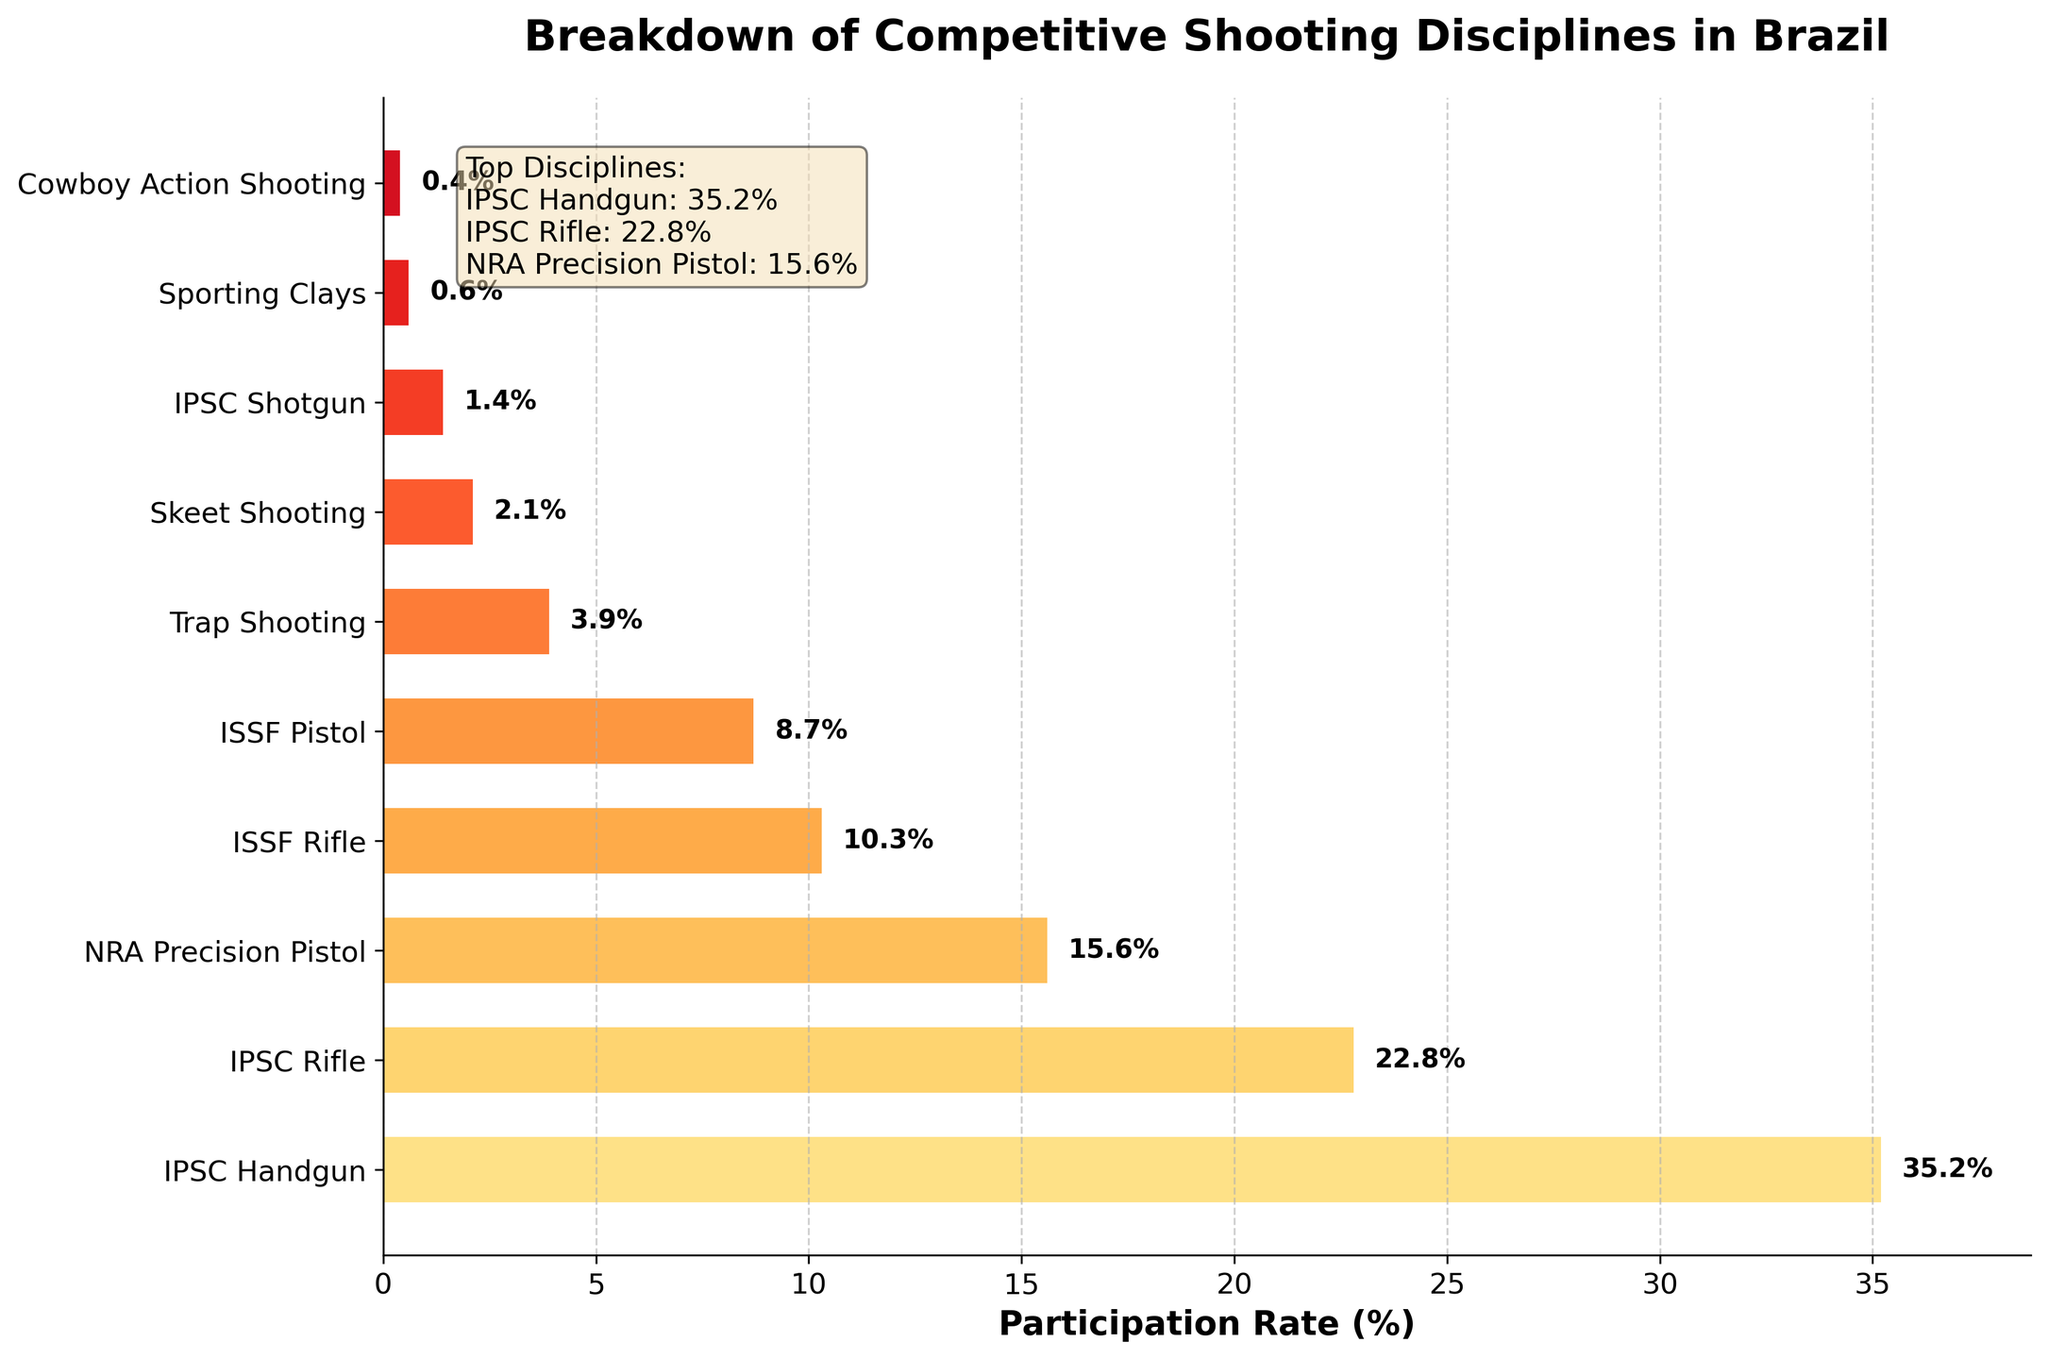What is the participation rate for IPSC Handgun? The figure shows a horizontal bar chart with participation rates. The bar for IPSC Handgun is labeled with its rate.
Answer: 35.2% Which discipline has the lowest participation rate? The figure shows several bars, each representing a discipline's participation rate. The shortest bar corresponds to Cowboy Action Shooting.
Answer: Cowboy Action Shooting How much higher is the participation rate for IPSC Handgun compared to ISSF Rifle? The participation rate for IPSC Handgun is 35.2%, and for ISSF Rifle, it is 10.3%. Subtracting the two rates (35.2% - 10.3%) gives the difference.
Answer: 24.9% What is the combined participation rate for all ISSF disciplines? The figure shows participation rates for ISSF Rifle (10.3%) and ISSF Pistol (8.7%). Adding the two rates (10.3% + 8.7%) gives the total.
Answer: 19% Which disciplines have a participation rate less than 5%? The figure has bars of different lengths. The bars for Trap Shooting (3.9%), Skeet Shooting (2.1%), IPSC Shotgun (1.4%), Sporting Clays (0.6%), and Cowboy Action Shooting (0.4%) are all less than 5%.
Answer: Trap Shooting, Skeet Shooting, IPSC Shotgun, Sporting Clays, Cowboy Action Shooting What is the average participation rate for the top three disciplines? The top three disciplines are IPSC Handgun (35.2%), IPSC Rifle (22.8%), and NRA Precision Pistol (15.6%). Adding these rates (35.2% + 22.8% + 15.6%) and dividing by 3 gives the average.
Answer: 24.53% How does the participation rate for Skeet Shooting compare to that for Trap Shooting? The figure shows that Skeet Shooting has a participation rate of 2.1%, and Trap Shooting has a rate of 3.9%. Skeet Shooting's rate is lower than Trap Shooting's.
Answer: Lower Is the participation rate for IPSC Shotgun greater than or equal to 1%? The figure shows that the participation rate for IPSC Shotgun is 1.4%. Since 1.4% is greater than 1%, the answer is yes.
Answer: Yes What is the difference between the participation rates of the highest and lowest disciplines? The highest participation rate is IPSC Handgun at 35.2%, and the lowest is Cowboy Action Shooting at 0.4%. Subtracting these rates (35.2% - 0.4%) gives the difference.
Answer: 34.8% Which discipline has the closest participation rate to 10%? The figure shows a bar for ISSF Rifle with a participation rate of 10.3%, which is closest to 10%.
Answer: ISSF Rifle 